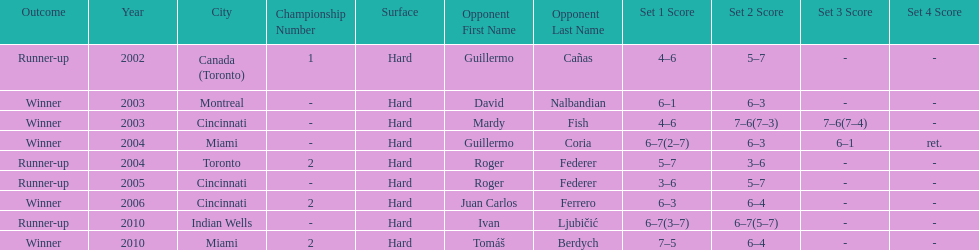How many total wins has he had? 5. 